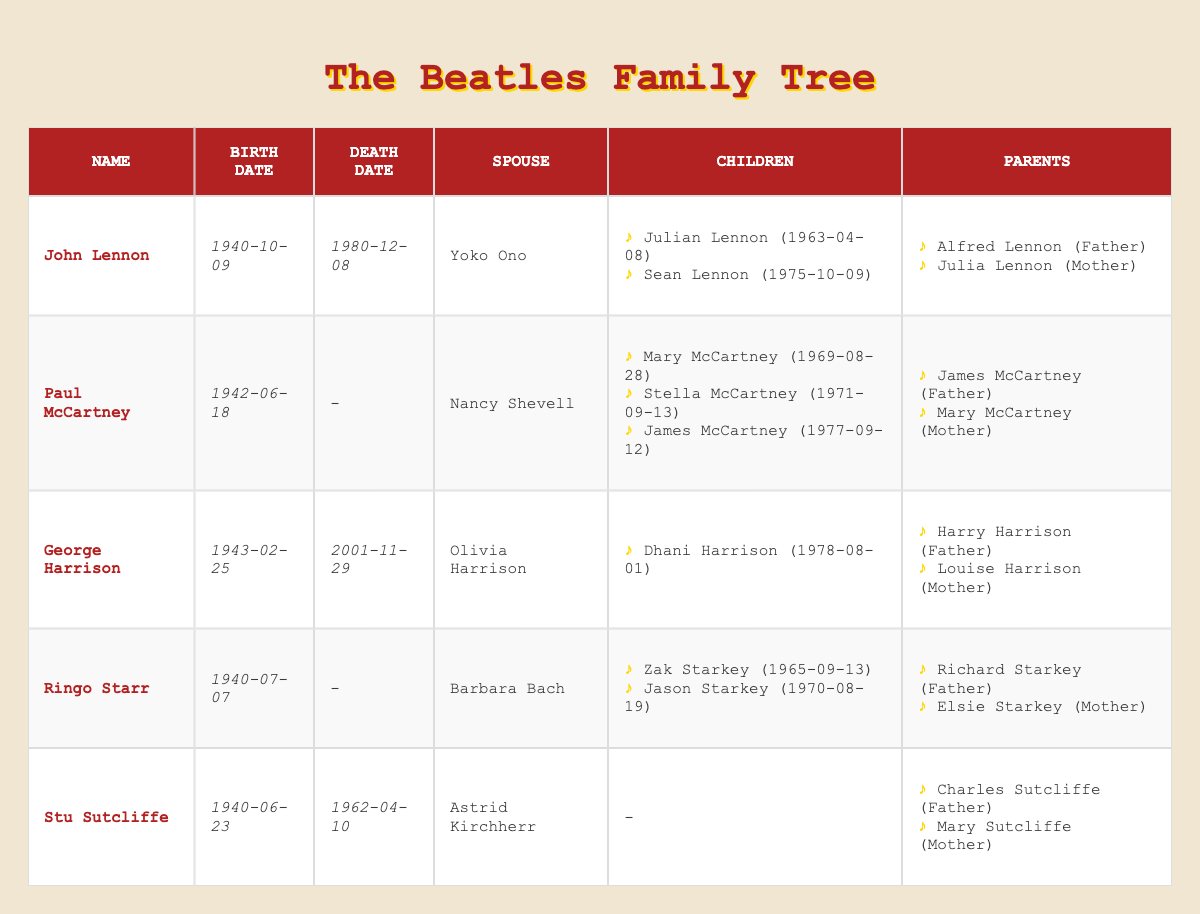What year was John Lennon born? According to the table, John Lennon's birth date is listed as 1940-10-09, therefore, he was born in 1940.
Answer: 1940 How many children does Paul McCartney have? The table shows that Paul McCartney has three children: Mary McCartney, Stella McCartney, and James McCartney. Therefore, he has three children.
Answer: 3 Who is Ringo Starr's spouse? The table states that Ringo Starr's spouse is Barbara Bach. Therefore, his spouse is Barbara Bach.
Answer: Barbara Bach Did George Harrison have any children? The table lists that George Harrison has one child, Dhani Harrison. Therefore, he did have children.
Answer: Yes What is the birth date of Sean Lennon? The table indicates that Sean Lennon's birth date is 1975-10-09. Thus, his birth date is 1975-10-09.
Answer: 1975-10-09 Who are the parents of Julian Lennon? From the table, it is seen that Julian Lennon is the child of John Lennon and Yoko Ono. Therefore, his parents are John Lennon and Yoko Ono.
Answer: John Lennon and Yoko Ono Which bandmate has the earliest birthdate? The birthdates listed are for John Lennon (1940), Paul McCartney (1942), George Harrison (1943), Ringo Starr (1940), and Stu Sutcliffe (1940). Comparing these, John Lennon and Ringo Starr share the earliest year, which is 1940.
Answer: John Lennon or Ringo Starr Is George Harrison still alive? The table specifies George Harrison's death date as 2001-11-29, indicating that he is deceased.
Answer: No How many parents does Stu Sutcliffe have? The table reveals that Stu Sutcliffe has two parents: Charles Sutcliffe (Father) and Mary Sutcliffe (Mother). Thus, he has two parents.
Answer: 2 Compare the number of children John Lennon and Ringo Starr have. John Lennon has two children (Julian and Sean), while Ringo Starr has two children (Zak and Jason). The counts are equal. Thus, they both have the same number of children.
Answer: Equal Who was the youngest among John Lennon, Paul McCartney, and George Harrison? Analyzing their birth years: John Lennon (1940), Paul McCartney (1942), and George Harrison (1943), it is clear that George Harrison, born in 1943, is the youngest among them.
Answer: George Harrison 